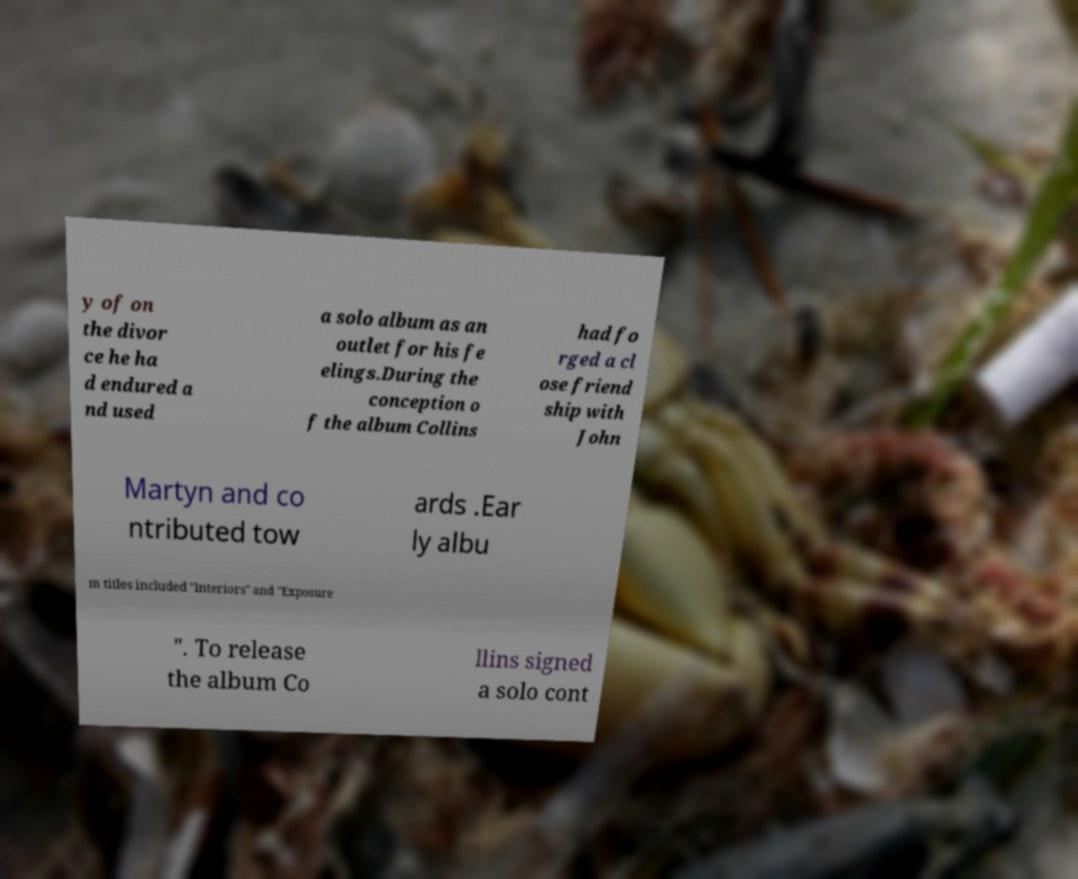Can you accurately transcribe the text from the provided image for me? y of on the divor ce he ha d endured a nd used a solo album as an outlet for his fe elings.During the conception o f the album Collins had fo rged a cl ose friend ship with John Martyn and co ntributed tow ards .Ear ly albu m titles included "Interiors" and "Exposure ". To release the album Co llins signed a solo cont 